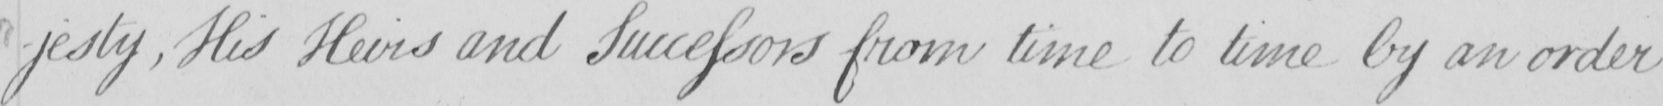What text is written in this handwritten line? -jesty , His Heirs and Successors from time to time by an order 